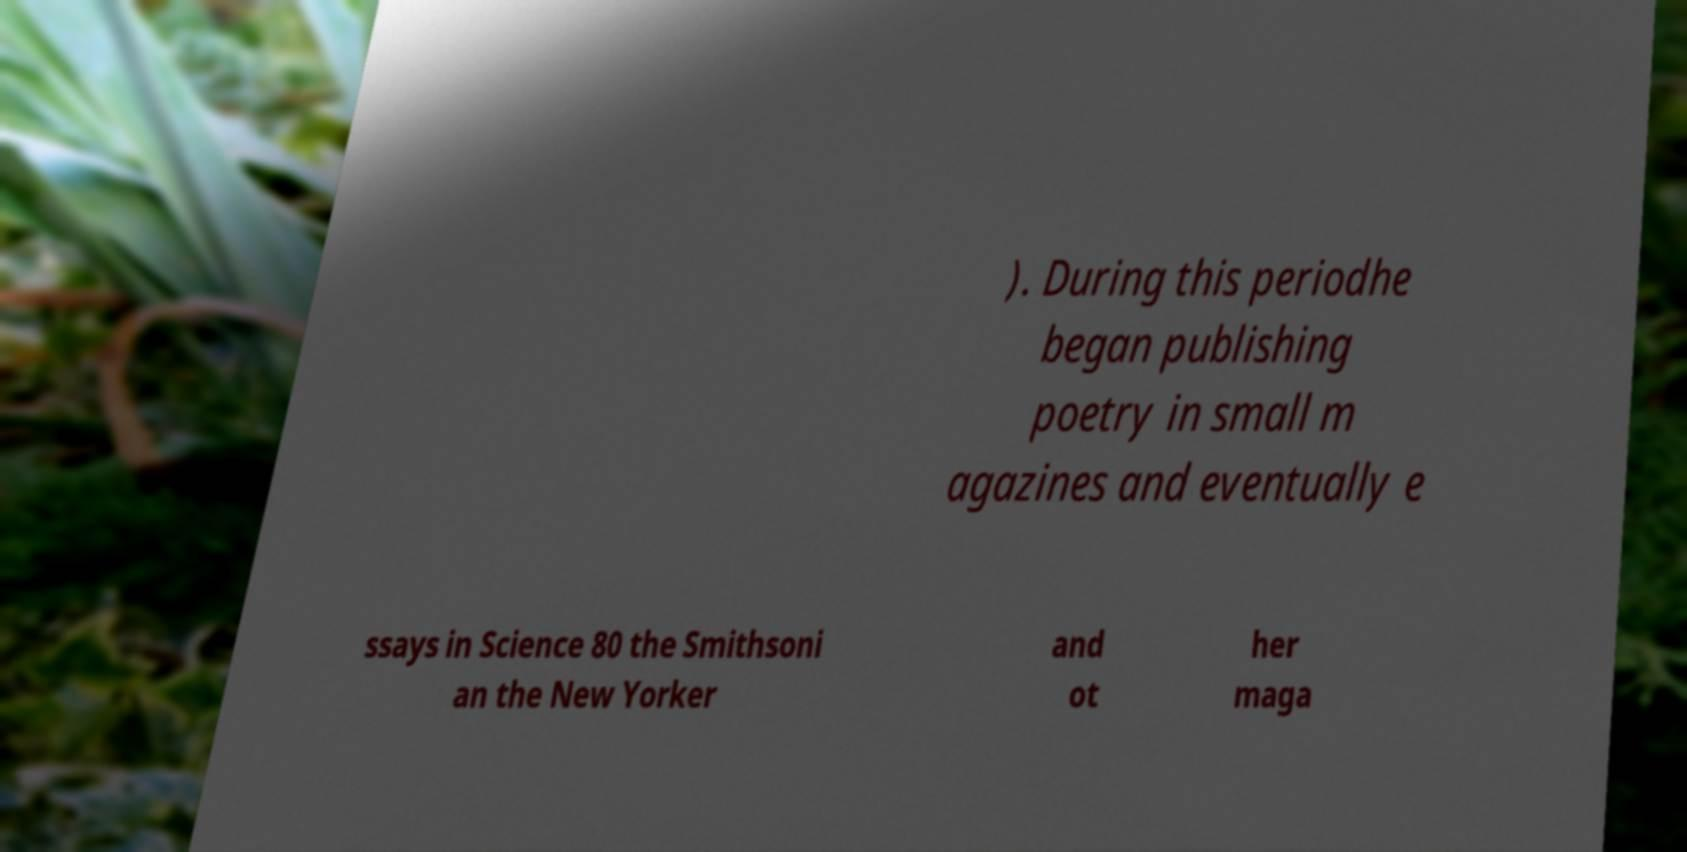What messages or text are displayed in this image? I need them in a readable, typed format. ). During this periodhe began publishing poetry in small m agazines and eventually e ssays in Science 80 the Smithsoni an the New Yorker and ot her maga 